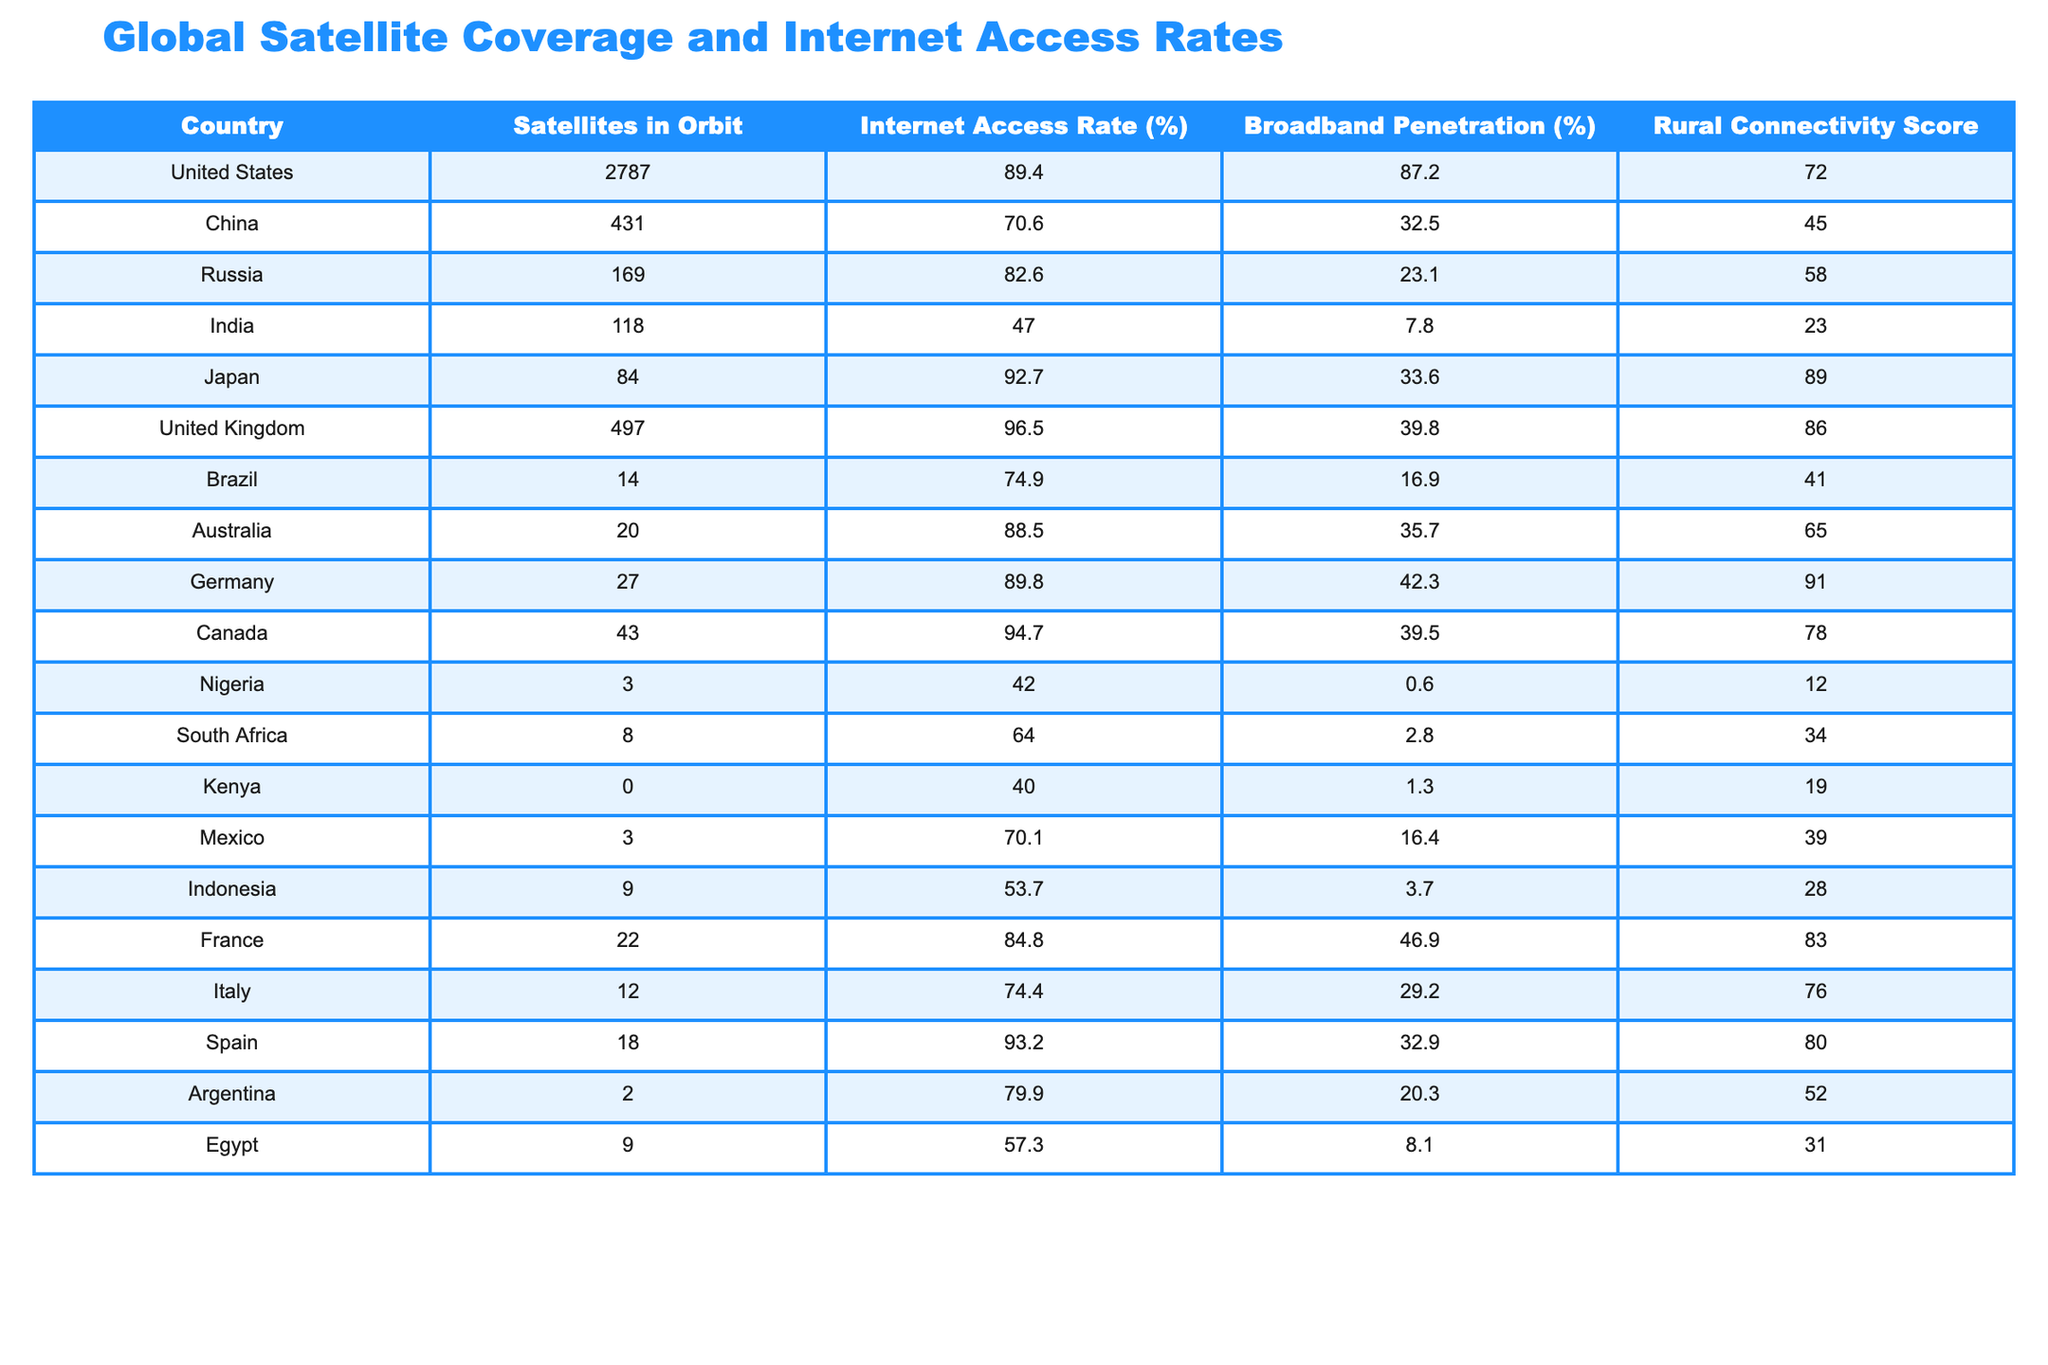What country has the highest internet access rate? The table shows the United Kingdom with an internet access rate of 96.5%, which is the highest among all listed countries.
Answer: United Kingdom Which country has the lowest rural connectivity score? From the table, Nigeria has the lowest rural connectivity score at 12.
Answer: Nigeria What is the internet access rate for Canada? According to the table, Canada has an internet access rate of 94.7%.
Answer: 94.7% Calculate the difference in broadband penetration between China and India. China's broadband penetration is 32.5% and India's is 7.8%. The difference is 32.5% - 7.8% = 24.7%.
Answer: 24.7% Which country has the most satellites in orbit and what is their internet access rate? The United States has the most satellites in orbit, with a count of 2787, and an internet access rate of 89.4%.
Answer: United States, 89.4% Is it true that both Japan and Germany have internet access rates above 90%? Yes, the table shows Japan at 92.7% and Germany at 89.8%. Since only Germany is below 90%, the statement is false.
Answer: False What is the average rural connectivity score of the top three countries by satellite count? The top three countries by satellite count are the United States (72), Russia (58), and China (45). The average is (72 + 58 + 45) / 3 = 58.33.
Answer: 58.33 Which country has the lowest internet access rate and what is it? India has the lowest internet access rate at 47.0%.
Answer: 47.0% How many more satellites does the United States have compared to Brazil? The United States has 2787 satellites, while Brazil has 14. The difference is 2787 - 14 = 2773.
Answer: 2773 What is the rural connectivity score for Egypt? According to the table, Egypt has a rural connectivity score of 31.
Answer: 31 